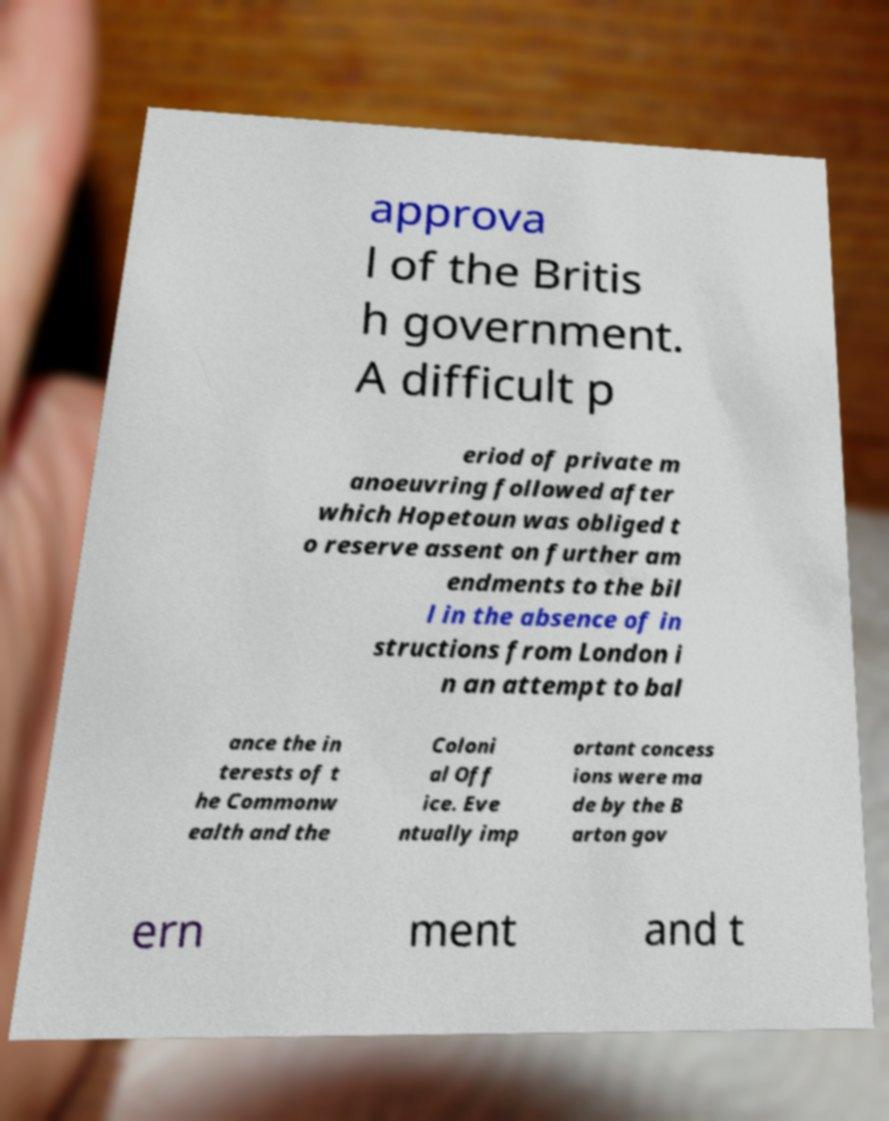Can you read and provide the text displayed in the image?This photo seems to have some interesting text. Can you extract and type it out for me? approva l of the Britis h government. A difficult p eriod of private m anoeuvring followed after which Hopetoun was obliged t o reserve assent on further am endments to the bil l in the absence of in structions from London i n an attempt to bal ance the in terests of t he Commonw ealth and the Coloni al Off ice. Eve ntually imp ortant concess ions were ma de by the B arton gov ern ment and t 